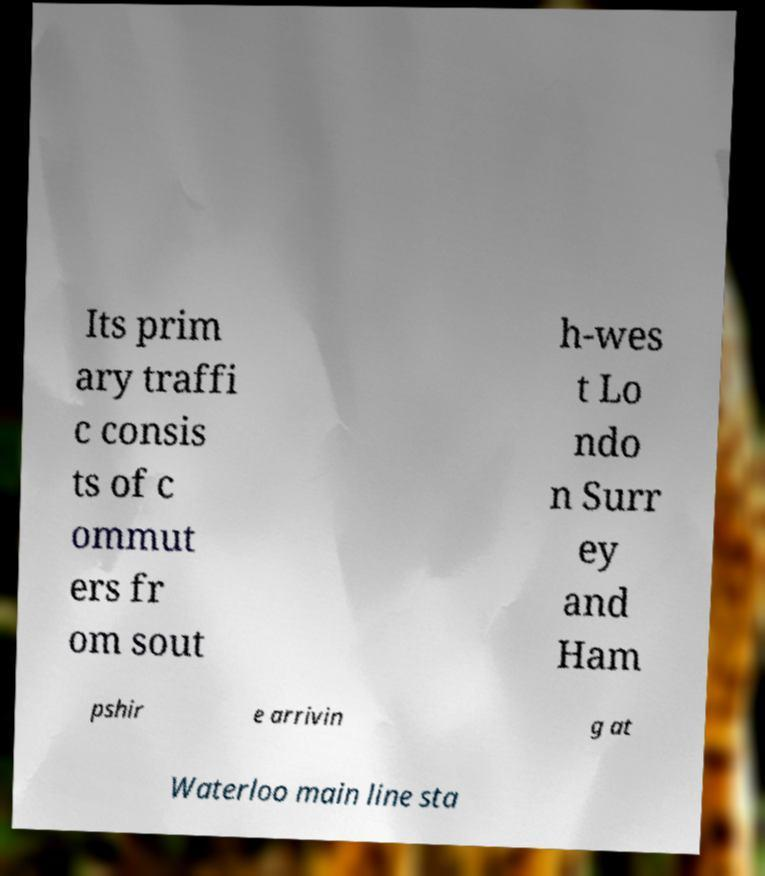For documentation purposes, I need the text within this image transcribed. Could you provide that? Its prim ary traffi c consis ts of c ommut ers fr om sout h-wes t Lo ndo n Surr ey and Ham pshir e arrivin g at Waterloo main line sta 